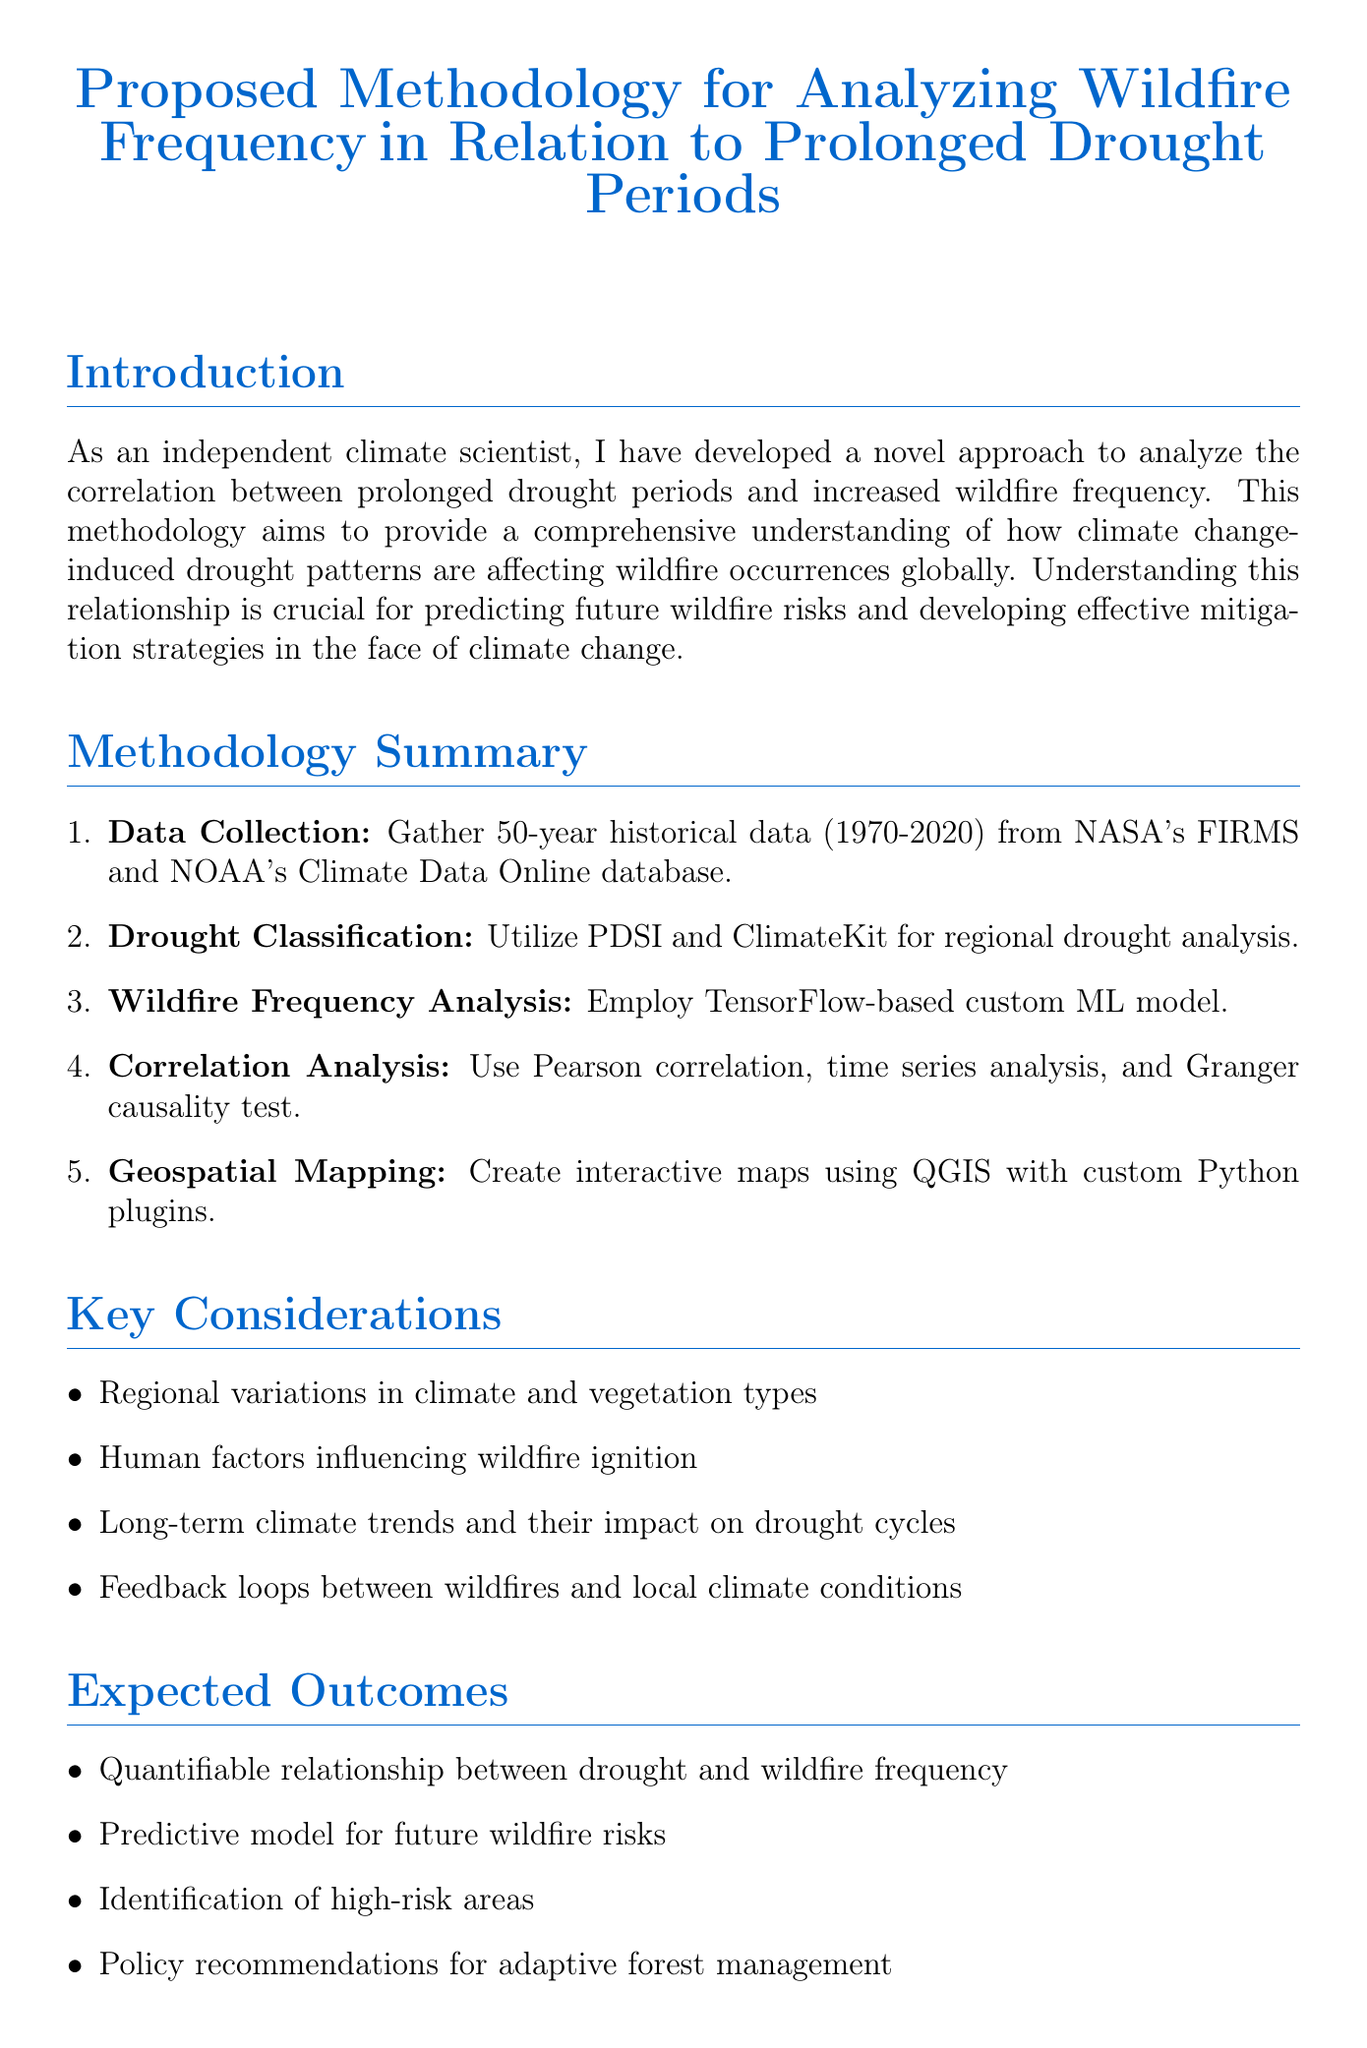what is the title of the memo? The title of the memo is clearly stated at the beginning of the document.
Answer: Proposed Methodology for Analyzing Wildfire Frequency in Relation to Prolonged Drought Periods which index is used for drought classification? The memo specifies the index utilized for classifying drought periods.
Answer: Palmer Drought Severity Index what machine learning framework is used for analysis? The document mentions the specific machine learning framework employed in the wildfire frequency analysis.
Answer: TensorFlow how long is the peer review period? The duration of the peer review phase is detailed in the timeline section of the memo.
Answer: 2 months what is the total duration for data collection? The timeline indicates the time allocated for data collection in the project.
Answer: 3 months which institution is responsible for data validation? The memo lists the collaborating institution associated with data validation.
Answer: University of California, Berkeley what type of maps will be created for visualization? The document describes the type of visual tools that will be generated in the methodology.
Answer: Interactive maps what is the expected outcome related to high-risk areas? The outcomes section highlights the identification of certain areas as an expected result.
Answer: Identification of high-risk areas for targeted wildfire prevention efforts which funding source is mentioned first? The memo lists the funding sources in a table format, indicating their order.
Answer: National Science Foundation how many statistical techniques are used in correlation analysis? The methodology section specifies the number of techniques employed in correlation analysis.
Answer: Three 